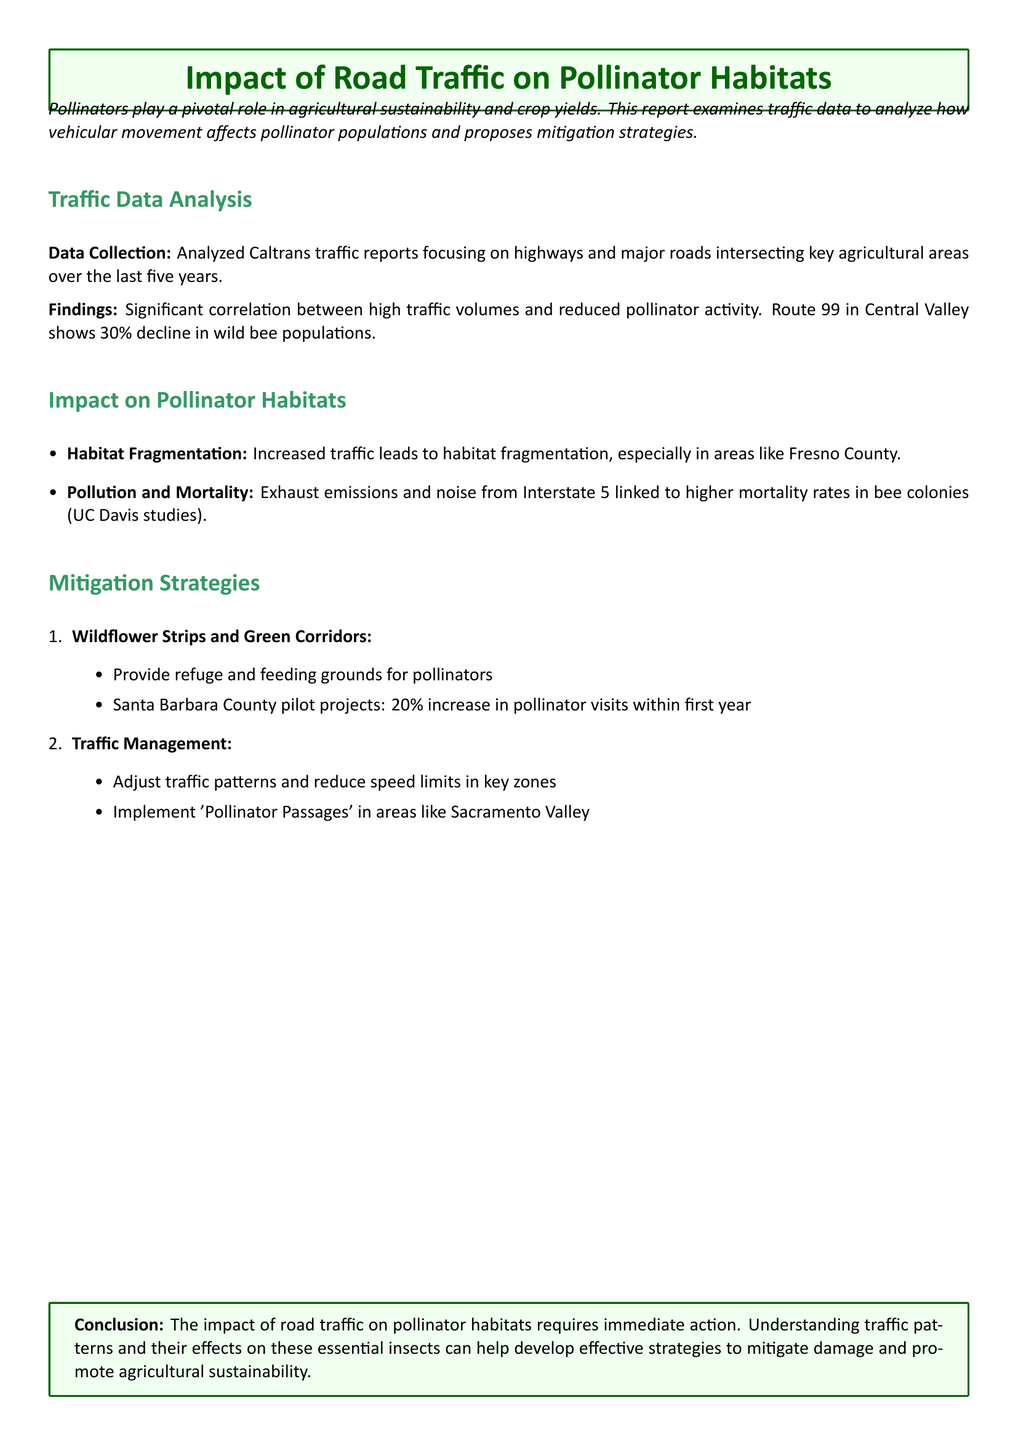What is the primary focus of the report? The report examines how vehicular movement affects pollinator populations and proposes mitigation strategies.
Answer: Pollinator populations What percentage decline was observed in wild bee populations on Route 99? The document states that Route 99 shows a 30% decline in wild bee populations.
Answer: 30% What type of pollution is linked to higher mortality rates in bee colonies? The report links exhaust emissions and noise from Interstate 5 to higher mortality rates in bee colonies.
Answer: Exhaust emissions Which county implemented pilot projects that increased pollinator visits by 20%? Santa Barbara County is mentioned as having pilot projects that resulted in increased pollinator visits.
Answer: Santa Barbara County What is one proposed mitigation strategy for enhancing pollinator habitats? The document suggests implementing wildflower strips and green corridors as a mitigation strategy.
Answer: Wildflower strips and green corridors What relationship does the report mention between traffic volume and pollinator activity? The report indicates a significant correlation between high traffic volumes and reduced pollinator activity.
Answer: Reduced pollinator activity What area's traffic patterns are suggested to be adjusted for traffic management? The report suggests adjusting traffic patterns in key zones, specifically mentioning Sacramento Valley.
Answer: Sacramento Valley What is a consequence of increased traffic according to the report? The report states that increased traffic leads to habitat fragmentation, especially in Fresno County.
Answer: Habitat fragmentation 